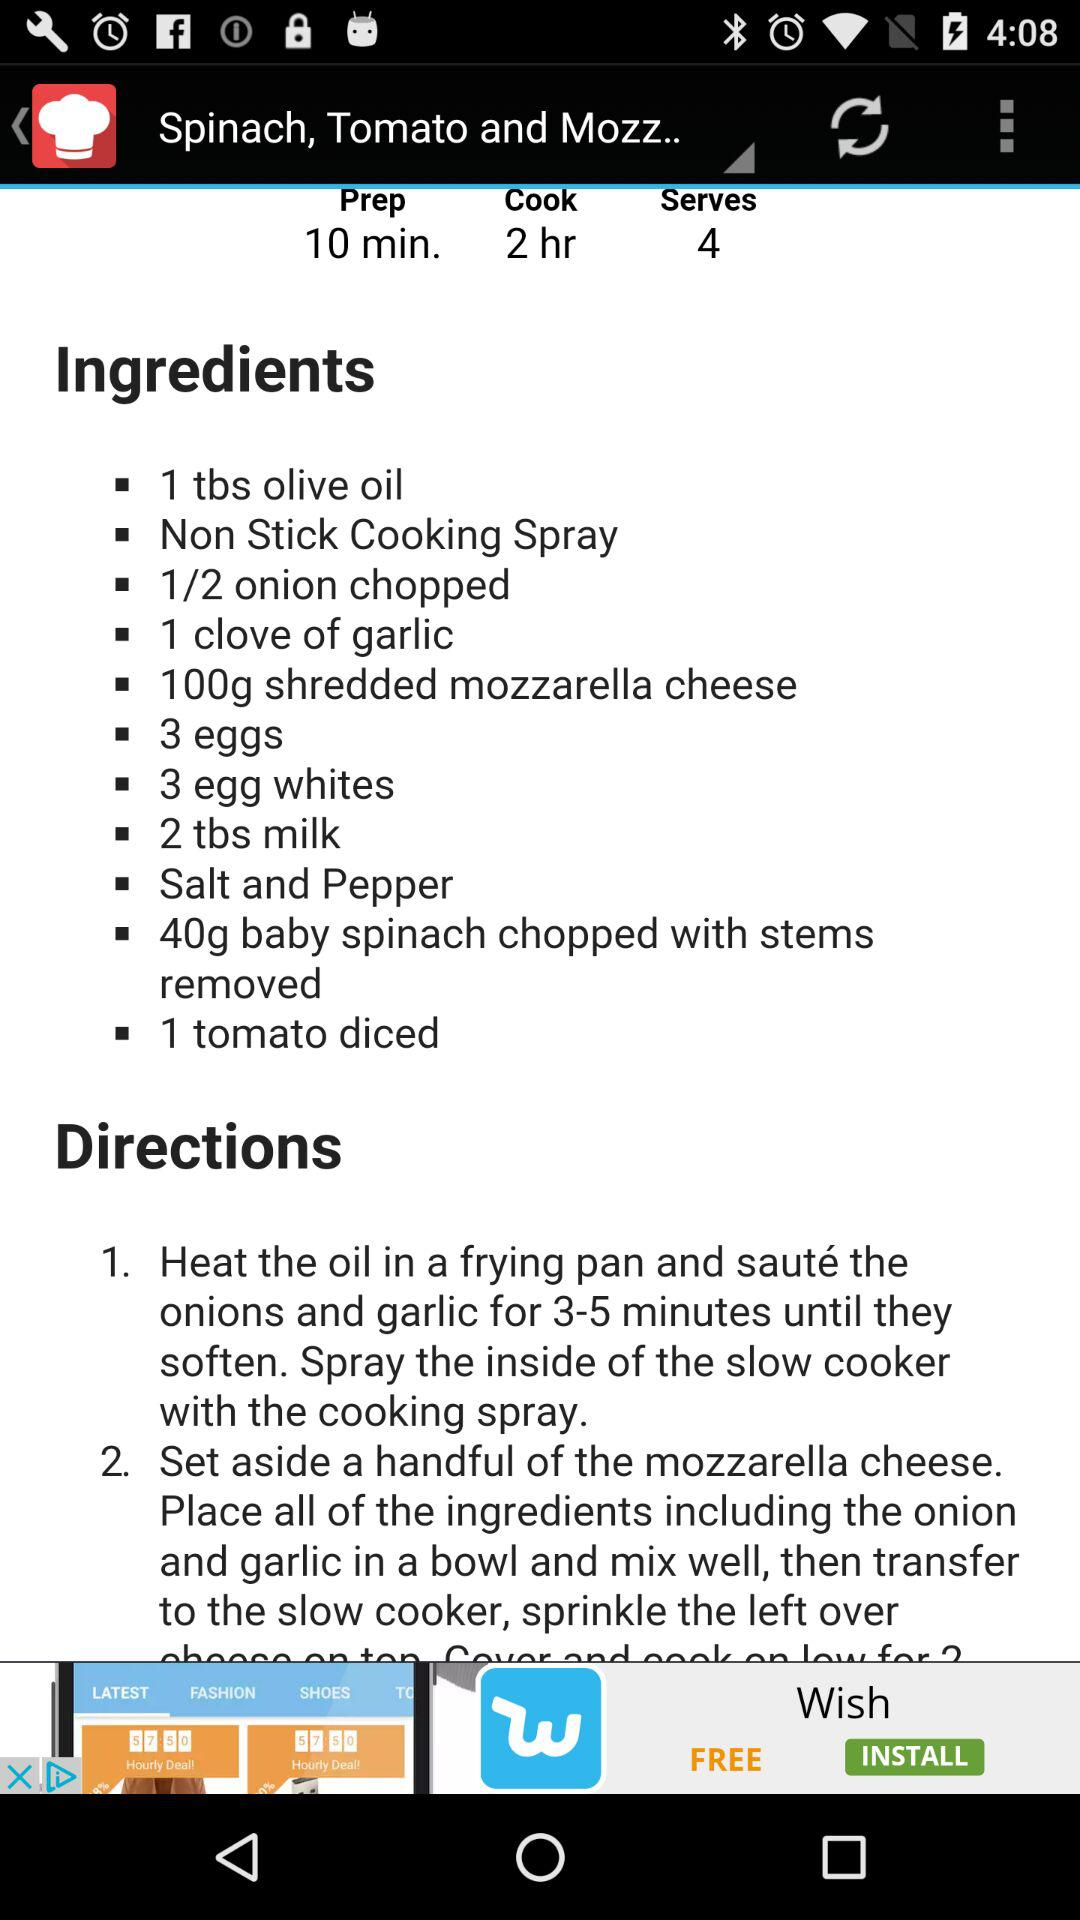How many minutes will it take to prepare the dish? It will take 10 minutes to prepare the dish. 